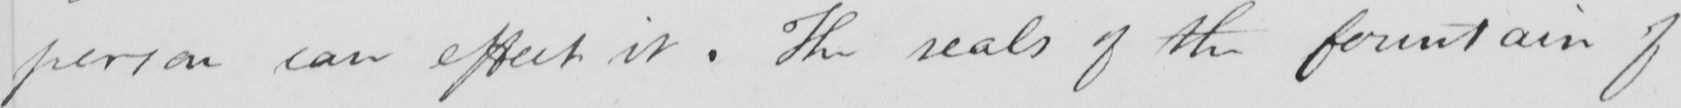Please transcribe the handwritten text in this image. person can effect it . The seals of the fountain of 